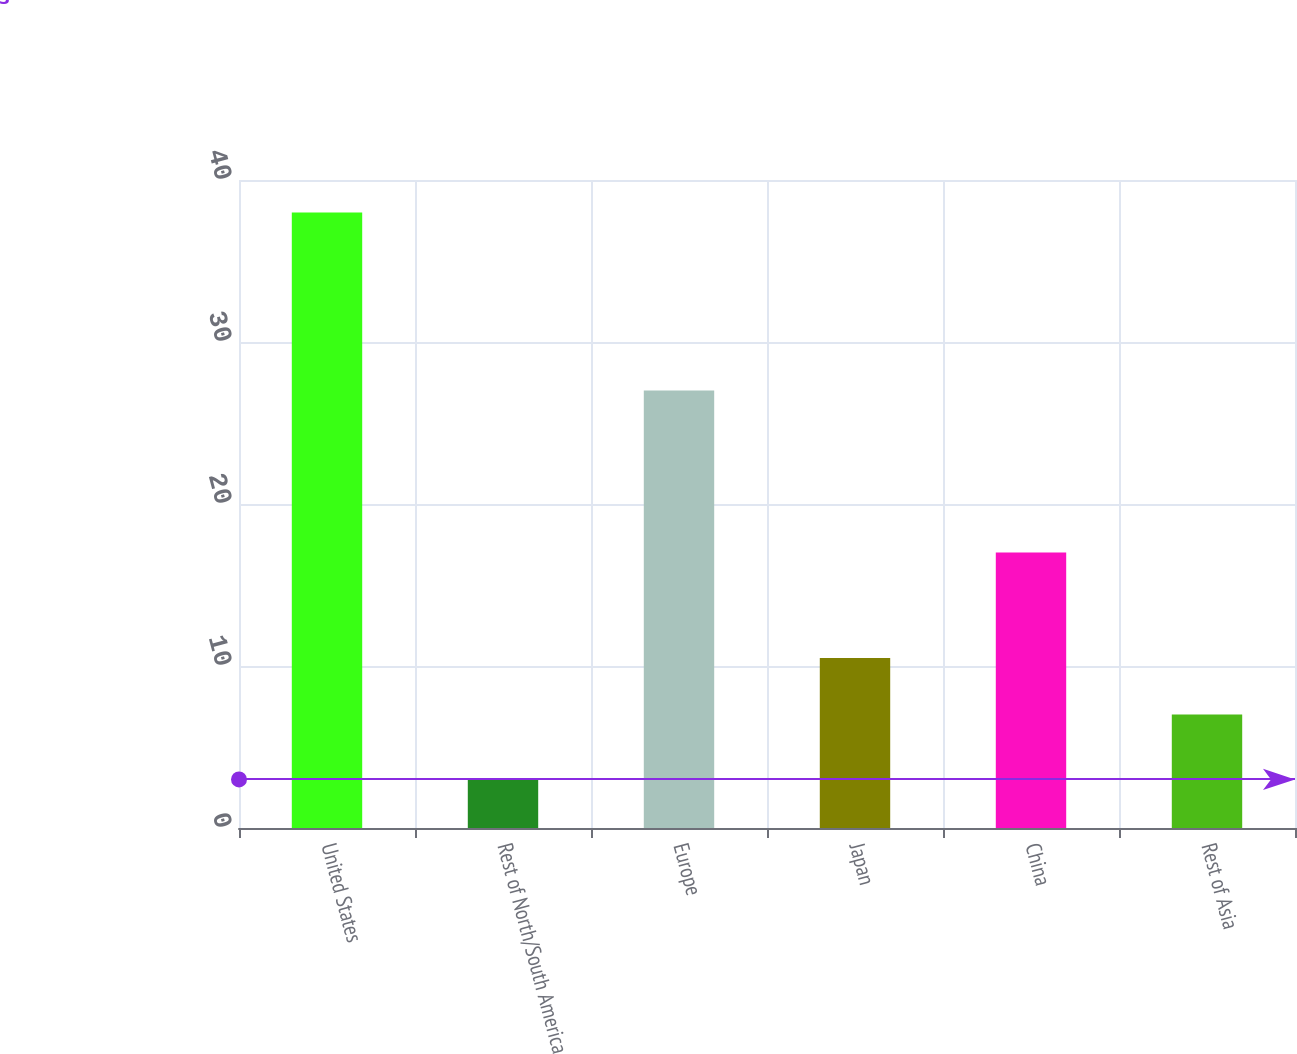Convert chart. <chart><loc_0><loc_0><loc_500><loc_500><bar_chart><fcel>United States<fcel>Rest of North/South America<fcel>Europe<fcel>Japan<fcel>China<fcel>Rest of Asia<nl><fcel>38<fcel>3<fcel>27<fcel>10.5<fcel>17<fcel>7<nl></chart> 